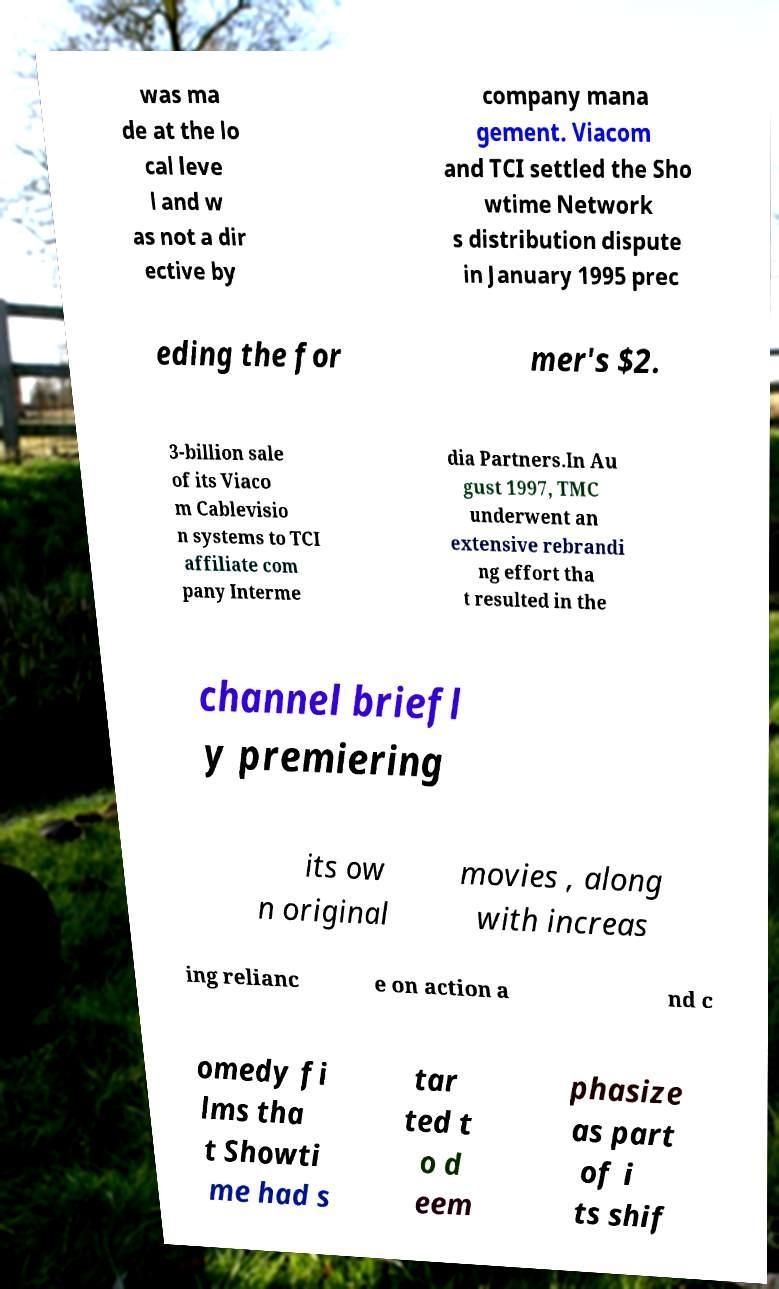Can you read and provide the text displayed in the image?This photo seems to have some interesting text. Can you extract and type it out for me? was ma de at the lo cal leve l and w as not a dir ective by company mana gement. Viacom and TCI settled the Sho wtime Network s distribution dispute in January 1995 prec eding the for mer's $2. 3-billion sale of its Viaco m Cablevisio n systems to TCI affiliate com pany Interme dia Partners.In Au gust 1997, TMC underwent an extensive rebrandi ng effort tha t resulted in the channel briefl y premiering its ow n original movies , along with increas ing relianc e on action a nd c omedy fi lms tha t Showti me had s tar ted t o d eem phasize as part of i ts shif 